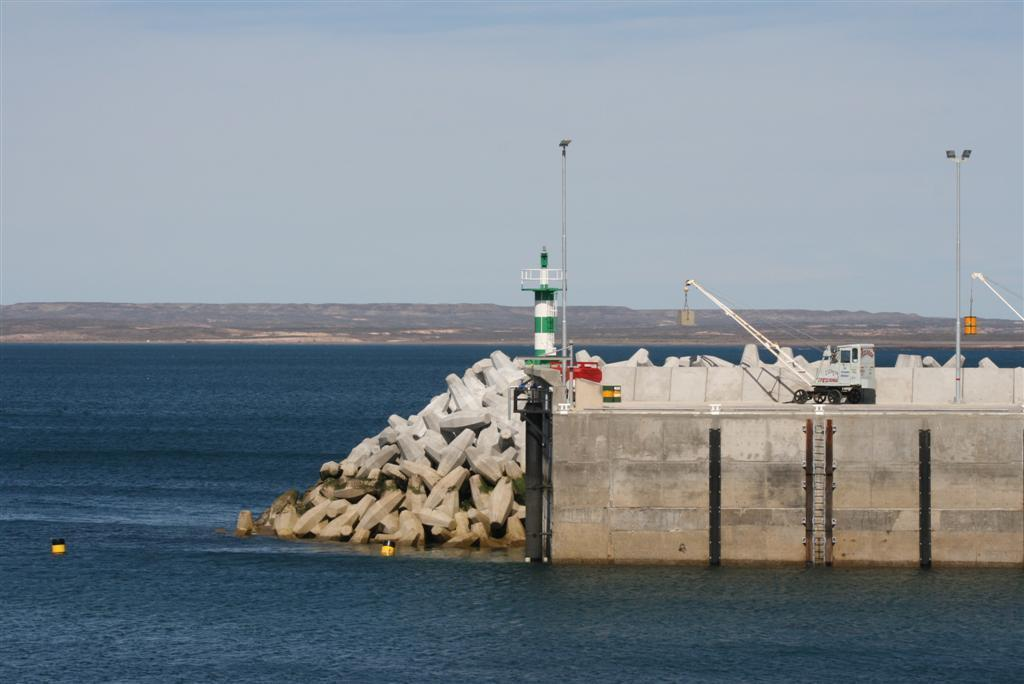What is located in the foreground of the image? In the foreground of the image, there is a fence, stones, a tower, poles, and a vehicle. Can you describe the objects in the foreground in more detail? The fence is made of wooden planks, the stones are scattered on the ground, the tower is tall and has a pointed roof, the poles are supporting wires, and the vehicle is a car. What can be seen in the background of the image? In the background of the image, there is water, mountains, and the sky. What might be the location of the image based on the background? The image may have been taken near the ocean, as there is water visible in the background. How does the self-driving car navigate the road in the image? There is no self-driving car present in the image; it is a regular car. What type of sea creatures can be seen swimming in the water in the image? There are no sea creatures visible in the image, as it only shows water in the background. 